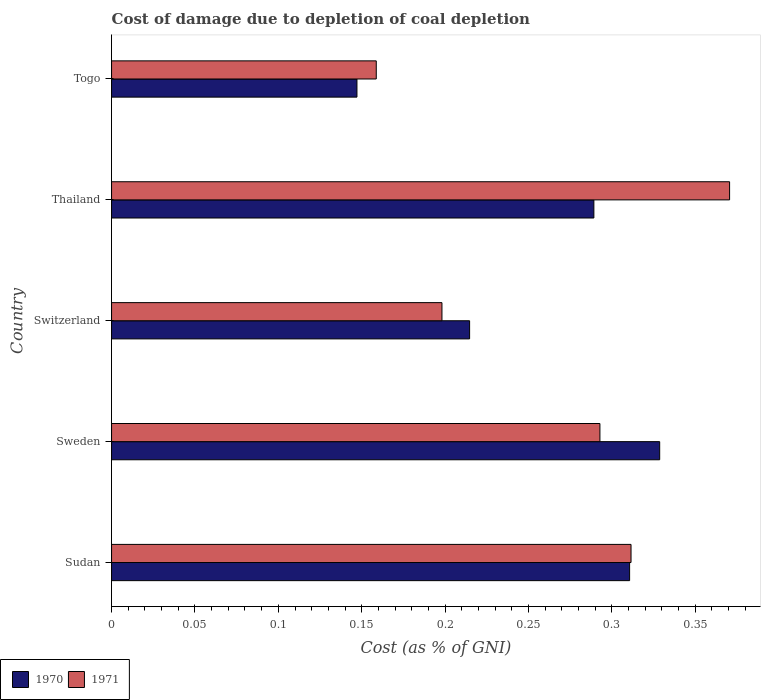How many different coloured bars are there?
Make the answer very short. 2. How many groups of bars are there?
Your answer should be compact. 5. Are the number of bars on each tick of the Y-axis equal?
Give a very brief answer. Yes. How many bars are there on the 3rd tick from the top?
Provide a short and direct response. 2. What is the label of the 1st group of bars from the top?
Make the answer very short. Togo. In how many cases, is the number of bars for a given country not equal to the number of legend labels?
Your answer should be very brief. 0. What is the cost of damage caused due to coal depletion in 1970 in Switzerland?
Keep it short and to the point. 0.21. Across all countries, what is the maximum cost of damage caused due to coal depletion in 1971?
Your response must be concise. 0.37. Across all countries, what is the minimum cost of damage caused due to coal depletion in 1970?
Provide a short and direct response. 0.15. In which country was the cost of damage caused due to coal depletion in 1970 maximum?
Offer a very short reply. Sweden. In which country was the cost of damage caused due to coal depletion in 1970 minimum?
Provide a succinct answer. Togo. What is the total cost of damage caused due to coal depletion in 1970 in the graph?
Ensure brevity in your answer.  1.29. What is the difference between the cost of damage caused due to coal depletion in 1970 in Sudan and that in Thailand?
Offer a terse response. 0.02. What is the difference between the cost of damage caused due to coal depletion in 1971 in Sweden and the cost of damage caused due to coal depletion in 1970 in Togo?
Offer a terse response. 0.15. What is the average cost of damage caused due to coal depletion in 1970 per country?
Ensure brevity in your answer.  0.26. What is the difference between the cost of damage caused due to coal depletion in 1971 and cost of damage caused due to coal depletion in 1970 in Togo?
Ensure brevity in your answer.  0.01. In how many countries, is the cost of damage caused due to coal depletion in 1970 greater than 0.18000000000000002 %?
Your answer should be compact. 4. What is the ratio of the cost of damage caused due to coal depletion in 1971 in Sudan to that in Thailand?
Make the answer very short. 0.84. Is the difference between the cost of damage caused due to coal depletion in 1971 in Sudan and Sweden greater than the difference between the cost of damage caused due to coal depletion in 1970 in Sudan and Sweden?
Your response must be concise. Yes. What is the difference between the highest and the second highest cost of damage caused due to coal depletion in 1970?
Give a very brief answer. 0.02. What is the difference between the highest and the lowest cost of damage caused due to coal depletion in 1970?
Offer a very short reply. 0.18. In how many countries, is the cost of damage caused due to coal depletion in 1971 greater than the average cost of damage caused due to coal depletion in 1971 taken over all countries?
Your answer should be very brief. 3. Is the sum of the cost of damage caused due to coal depletion in 1970 in Switzerland and Thailand greater than the maximum cost of damage caused due to coal depletion in 1971 across all countries?
Make the answer very short. Yes. What does the 2nd bar from the top in Thailand represents?
Your answer should be very brief. 1970. How many countries are there in the graph?
Your answer should be very brief. 5. What is the title of the graph?
Keep it short and to the point. Cost of damage due to depletion of coal depletion. What is the label or title of the X-axis?
Offer a terse response. Cost (as % of GNI). What is the label or title of the Y-axis?
Your response must be concise. Country. What is the Cost (as % of GNI) of 1970 in Sudan?
Offer a terse response. 0.31. What is the Cost (as % of GNI) of 1971 in Sudan?
Keep it short and to the point. 0.31. What is the Cost (as % of GNI) of 1970 in Sweden?
Ensure brevity in your answer.  0.33. What is the Cost (as % of GNI) in 1971 in Sweden?
Keep it short and to the point. 0.29. What is the Cost (as % of GNI) of 1970 in Switzerland?
Provide a short and direct response. 0.21. What is the Cost (as % of GNI) of 1971 in Switzerland?
Give a very brief answer. 0.2. What is the Cost (as % of GNI) in 1970 in Thailand?
Your answer should be compact. 0.29. What is the Cost (as % of GNI) in 1971 in Thailand?
Provide a short and direct response. 0.37. What is the Cost (as % of GNI) in 1970 in Togo?
Your answer should be very brief. 0.15. What is the Cost (as % of GNI) of 1971 in Togo?
Make the answer very short. 0.16. Across all countries, what is the maximum Cost (as % of GNI) in 1970?
Ensure brevity in your answer.  0.33. Across all countries, what is the maximum Cost (as % of GNI) in 1971?
Ensure brevity in your answer.  0.37. Across all countries, what is the minimum Cost (as % of GNI) of 1970?
Give a very brief answer. 0.15. Across all countries, what is the minimum Cost (as % of GNI) in 1971?
Ensure brevity in your answer.  0.16. What is the total Cost (as % of GNI) of 1970 in the graph?
Your answer should be compact. 1.29. What is the total Cost (as % of GNI) in 1971 in the graph?
Offer a very short reply. 1.33. What is the difference between the Cost (as % of GNI) of 1970 in Sudan and that in Sweden?
Offer a terse response. -0.02. What is the difference between the Cost (as % of GNI) in 1971 in Sudan and that in Sweden?
Give a very brief answer. 0.02. What is the difference between the Cost (as % of GNI) in 1970 in Sudan and that in Switzerland?
Keep it short and to the point. 0.1. What is the difference between the Cost (as % of GNI) of 1971 in Sudan and that in Switzerland?
Ensure brevity in your answer.  0.11. What is the difference between the Cost (as % of GNI) of 1970 in Sudan and that in Thailand?
Provide a short and direct response. 0.02. What is the difference between the Cost (as % of GNI) in 1971 in Sudan and that in Thailand?
Provide a short and direct response. -0.06. What is the difference between the Cost (as % of GNI) of 1970 in Sudan and that in Togo?
Your answer should be very brief. 0.16. What is the difference between the Cost (as % of GNI) in 1971 in Sudan and that in Togo?
Give a very brief answer. 0.15. What is the difference between the Cost (as % of GNI) of 1970 in Sweden and that in Switzerland?
Ensure brevity in your answer.  0.11. What is the difference between the Cost (as % of GNI) in 1971 in Sweden and that in Switzerland?
Offer a terse response. 0.09. What is the difference between the Cost (as % of GNI) of 1970 in Sweden and that in Thailand?
Provide a succinct answer. 0.04. What is the difference between the Cost (as % of GNI) in 1971 in Sweden and that in Thailand?
Offer a very short reply. -0.08. What is the difference between the Cost (as % of GNI) in 1970 in Sweden and that in Togo?
Offer a very short reply. 0.18. What is the difference between the Cost (as % of GNI) in 1971 in Sweden and that in Togo?
Offer a very short reply. 0.13. What is the difference between the Cost (as % of GNI) in 1970 in Switzerland and that in Thailand?
Ensure brevity in your answer.  -0.07. What is the difference between the Cost (as % of GNI) in 1971 in Switzerland and that in Thailand?
Give a very brief answer. -0.17. What is the difference between the Cost (as % of GNI) in 1970 in Switzerland and that in Togo?
Ensure brevity in your answer.  0.07. What is the difference between the Cost (as % of GNI) of 1971 in Switzerland and that in Togo?
Provide a succinct answer. 0.04. What is the difference between the Cost (as % of GNI) in 1970 in Thailand and that in Togo?
Your response must be concise. 0.14. What is the difference between the Cost (as % of GNI) of 1971 in Thailand and that in Togo?
Your answer should be compact. 0.21. What is the difference between the Cost (as % of GNI) in 1970 in Sudan and the Cost (as % of GNI) in 1971 in Sweden?
Offer a terse response. 0.02. What is the difference between the Cost (as % of GNI) in 1970 in Sudan and the Cost (as % of GNI) in 1971 in Switzerland?
Make the answer very short. 0.11. What is the difference between the Cost (as % of GNI) of 1970 in Sudan and the Cost (as % of GNI) of 1971 in Thailand?
Your response must be concise. -0.06. What is the difference between the Cost (as % of GNI) in 1970 in Sudan and the Cost (as % of GNI) in 1971 in Togo?
Your response must be concise. 0.15. What is the difference between the Cost (as % of GNI) of 1970 in Sweden and the Cost (as % of GNI) of 1971 in Switzerland?
Your answer should be very brief. 0.13. What is the difference between the Cost (as % of GNI) in 1970 in Sweden and the Cost (as % of GNI) in 1971 in Thailand?
Your answer should be compact. -0.04. What is the difference between the Cost (as % of GNI) in 1970 in Sweden and the Cost (as % of GNI) in 1971 in Togo?
Provide a short and direct response. 0.17. What is the difference between the Cost (as % of GNI) in 1970 in Switzerland and the Cost (as % of GNI) in 1971 in Thailand?
Keep it short and to the point. -0.16. What is the difference between the Cost (as % of GNI) of 1970 in Switzerland and the Cost (as % of GNI) of 1971 in Togo?
Offer a very short reply. 0.06. What is the difference between the Cost (as % of GNI) of 1970 in Thailand and the Cost (as % of GNI) of 1971 in Togo?
Provide a short and direct response. 0.13. What is the average Cost (as % of GNI) of 1970 per country?
Ensure brevity in your answer.  0.26. What is the average Cost (as % of GNI) of 1971 per country?
Your answer should be very brief. 0.27. What is the difference between the Cost (as % of GNI) in 1970 and Cost (as % of GNI) in 1971 in Sudan?
Provide a short and direct response. -0. What is the difference between the Cost (as % of GNI) in 1970 and Cost (as % of GNI) in 1971 in Sweden?
Make the answer very short. 0.04. What is the difference between the Cost (as % of GNI) in 1970 and Cost (as % of GNI) in 1971 in Switzerland?
Your answer should be compact. 0.02. What is the difference between the Cost (as % of GNI) of 1970 and Cost (as % of GNI) of 1971 in Thailand?
Your answer should be very brief. -0.08. What is the difference between the Cost (as % of GNI) in 1970 and Cost (as % of GNI) in 1971 in Togo?
Keep it short and to the point. -0.01. What is the ratio of the Cost (as % of GNI) of 1970 in Sudan to that in Sweden?
Offer a very short reply. 0.95. What is the ratio of the Cost (as % of GNI) in 1971 in Sudan to that in Sweden?
Keep it short and to the point. 1.06. What is the ratio of the Cost (as % of GNI) of 1970 in Sudan to that in Switzerland?
Your answer should be compact. 1.45. What is the ratio of the Cost (as % of GNI) of 1971 in Sudan to that in Switzerland?
Ensure brevity in your answer.  1.57. What is the ratio of the Cost (as % of GNI) in 1970 in Sudan to that in Thailand?
Keep it short and to the point. 1.07. What is the ratio of the Cost (as % of GNI) of 1971 in Sudan to that in Thailand?
Offer a terse response. 0.84. What is the ratio of the Cost (as % of GNI) in 1970 in Sudan to that in Togo?
Offer a terse response. 2.11. What is the ratio of the Cost (as % of GNI) of 1971 in Sudan to that in Togo?
Your response must be concise. 1.96. What is the ratio of the Cost (as % of GNI) of 1970 in Sweden to that in Switzerland?
Provide a short and direct response. 1.53. What is the ratio of the Cost (as % of GNI) of 1971 in Sweden to that in Switzerland?
Provide a short and direct response. 1.48. What is the ratio of the Cost (as % of GNI) of 1970 in Sweden to that in Thailand?
Offer a very short reply. 1.14. What is the ratio of the Cost (as % of GNI) of 1971 in Sweden to that in Thailand?
Keep it short and to the point. 0.79. What is the ratio of the Cost (as % of GNI) in 1970 in Sweden to that in Togo?
Your answer should be compact. 2.23. What is the ratio of the Cost (as % of GNI) of 1971 in Sweden to that in Togo?
Make the answer very short. 1.84. What is the ratio of the Cost (as % of GNI) in 1970 in Switzerland to that in Thailand?
Make the answer very short. 0.74. What is the ratio of the Cost (as % of GNI) of 1971 in Switzerland to that in Thailand?
Ensure brevity in your answer.  0.53. What is the ratio of the Cost (as % of GNI) of 1970 in Switzerland to that in Togo?
Your answer should be very brief. 1.46. What is the ratio of the Cost (as % of GNI) of 1971 in Switzerland to that in Togo?
Your answer should be very brief. 1.25. What is the ratio of the Cost (as % of GNI) in 1970 in Thailand to that in Togo?
Make the answer very short. 1.97. What is the ratio of the Cost (as % of GNI) of 1971 in Thailand to that in Togo?
Offer a terse response. 2.33. What is the difference between the highest and the second highest Cost (as % of GNI) in 1970?
Ensure brevity in your answer.  0.02. What is the difference between the highest and the second highest Cost (as % of GNI) of 1971?
Keep it short and to the point. 0.06. What is the difference between the highest and the lowest Cost (as % of GNI) in 1970?
Ensure brevity in your answer.  0.18. What is the difference between the highest and the lowest Cost (as % of GNI) in 1971?
Ensure brevity in your answer.  0.21. 